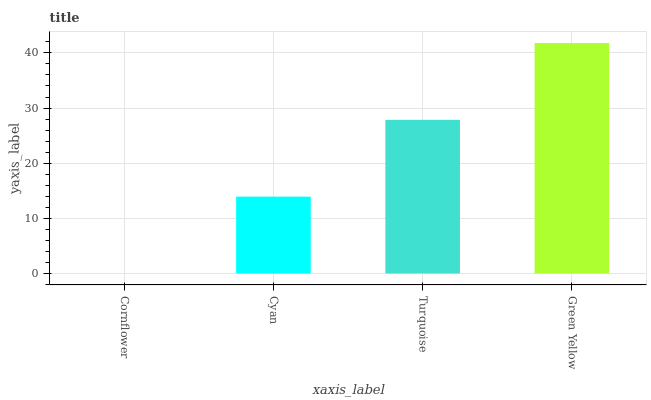Is Cornflower the minimum?
Answer yes or no. Yes. Is Green Yellow the maximum?
Answer yes or no. Yes. Is Cyan the minimum?
Answer yes or no. No. Is Cyan the maximum?
Answer yes or no. No. Is Cyan greater than Cornflower?
Answer yes or no. Yes. Is Cornflower less than Cyan?
Answer yes or no. Yes. Is Cornflower greater than Cyan?
Answer yes or no. No. Is Cyan less than Cornflower?
Answer yes or no. No. Is Turquoise the high median?
Answer yes or no. Yes. Is Cyan the low median?
Answer yes or no. Yes. Is Cornflower the high median?
Answer yes or no. No. Is Green Yellow the low median?
Answer yes or no. No. 